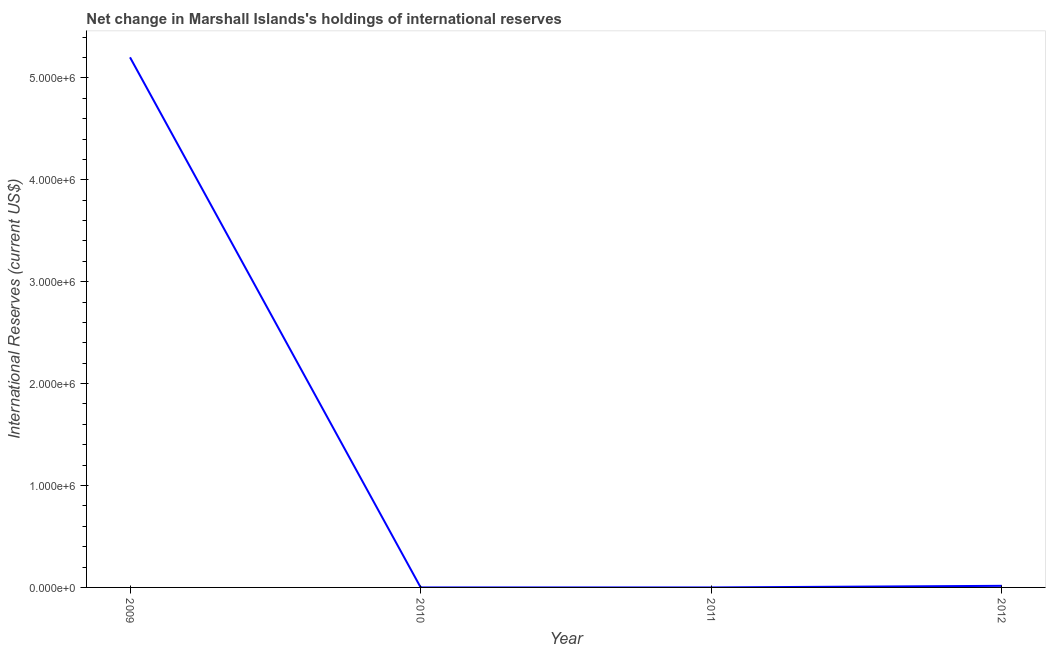What is the reserves and related items in 2010?
Ensure brevity in your answer.  0. Across all years, what is the maximum reserves and related items?
Ensure brevity in your answer.  5.20e+06. Across all years, what is the minimum reserves and related items?
Offer a terse response. 0. What is the sum of the reserves and related items?
Offer a terse response. 5.22e+06. What is the difference between the reserves and related items in 2009 and 2012?
Provide a short and direct response. 5.19e+06. What is the average reserves and related items per year?
Offer a very short reply. 1.30e+06. What is the median reserves and related items?
Provide a short and direct response. 7873.09. In how many years, is the reserves and related items greater than 3200000 US$?
Offer a very short reply. 1. Is the reserves and related items in 2009 less than that in 2012?
Offer a terse response. No. Is the difference between the reserves and related items in 2009 and 2012 greater than the difference between any two years?
Offer a very short reply. No. What is the difference between the highest and the lowest reserves and related items?
Your answer should be very brief. 5.20e+06. In how many years, is the reserves and related items greater than the average reserves and related items taken over all years?
Provide a short and direct response. 1. How many years are there in the graph?
Provide a succinct answer. 4. Does the graph contain any zero values?
Offer a terse response. Yes. Does the graph contain grids?
Make the answer very short. No. What is the title of the graph?
Ensure brevity in your answer.  Net change in Marshall Islands's holdings of international reserves. What is the label or title of the X-axis?
Offer a terse response. Year. What is the label or title of the Y-axis?
Offer a very short reply. International Reserves (current US$). What is the International Reserves (current US$) of 2009?
Provide a succinct answer. 5.20e+06. What is the International Reserves (current US$) in 2012?
Offer a very short reply. 1.57e+04. What is the difference between the International Reserves (current US$) in 2009 and 2012?
Offer a terse response. 5.19e+06. What is the ratio of the International Reserves (current US$) in 2009 to that in 2012?
Provide a succinct answer. 330.35. 